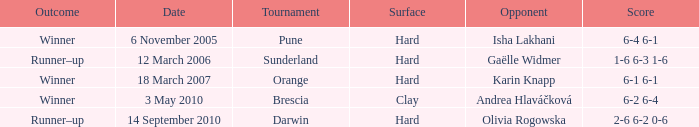Can you give me this table as a dict? {'header': ['Outcome', 'Date', 'Tournament', 'Surface', 'Opponent', 'Score'], 'rows': [['Winner', '6 November 2005', 'Pune', 'Hard', 'Isha Lakhani', '6-4 6-1'], ['Runner–up', '12 March 2006', 'Sunderland', 'Hard', 'Gaëlle Widmer', '1-6 6-3 1-6'], ['Winner', '18 March 2007', 'Orange', 'Hard', 'Karin Knapp', '6-1 6-1'], ['Winner', '3 May 2010', 'Brescia', 'Clay', 'Andrea Hlaváčková', '6-2 6-4'], ['Runner–up', '14 September 2010', 'Darwin', 'Hard', 'Olivia Rogowska', '2-6 6-2 0-6']]} What was the tournament's score when competing against isha lakhani? 6-4 6-1. 